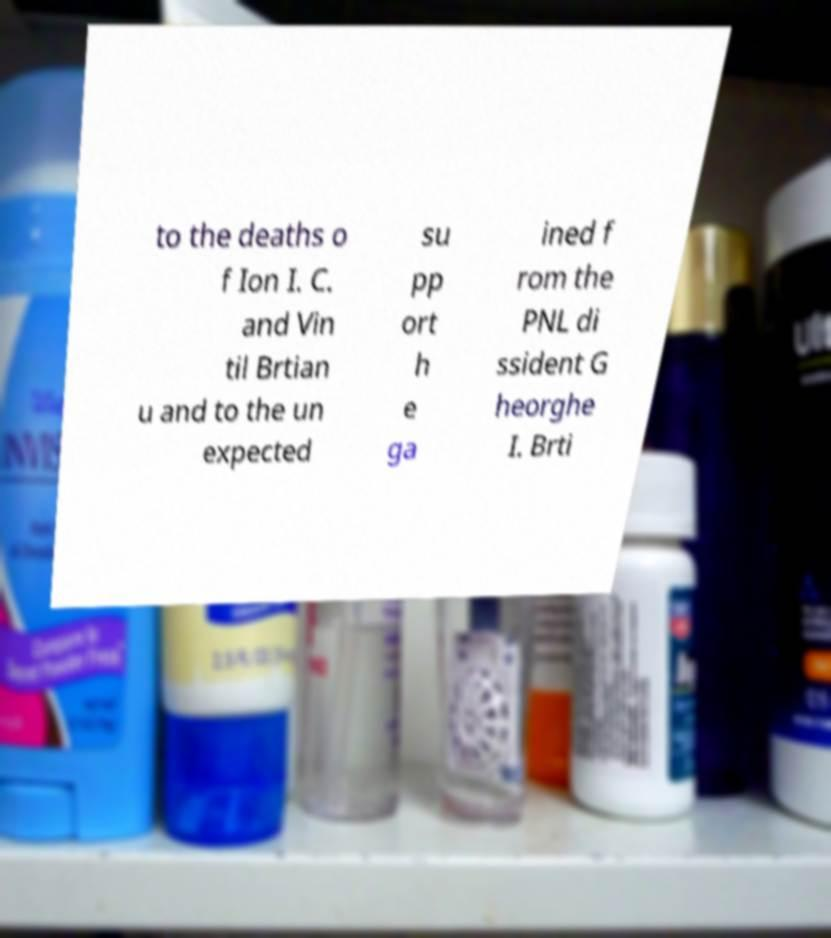Could you extract and type out the text from this image? to the deaths o f Ion I. C. and Vin til Brtian u and to the un expected su pp ort h e ga ined f rom the PNL di ssident G heorghe I. Brti 